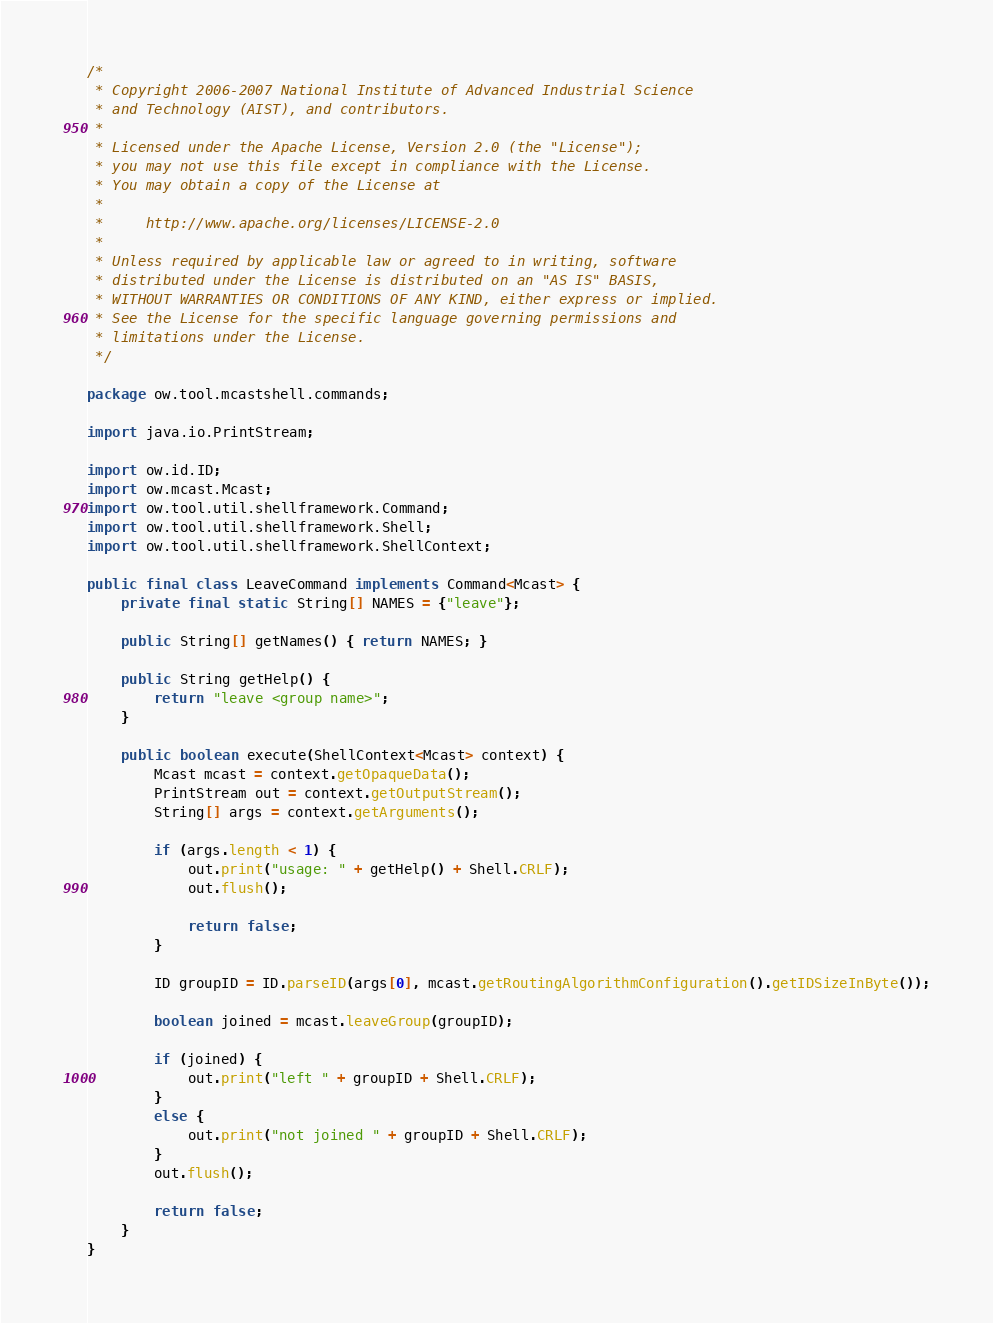<code> <loc_0><loc_0><loc_500><loc_500><_Java_>/*
 * Copyright 2006-2007 National Institute of Advanced Industrial Science
 * and Technology (AIST), and contributors.
 *
 * Licensed under the Apache License, Version 2.0 (the "License");
 * you may not use this file except in compliance with the License.
 * You may obtain a copy of the License at
 *
 *     http://www.apache.org/licenses/LICENSE-2.0
 *
 * Unless required by applicable law or agreed to in writing, software
 * distributed under the License is distributed on an "AS IS" BASIS,
 * WITHOUT WARRANTIES OR CONDITIONS OF ANY KIND, either express or implied.
 * See the License for the specific language governing permissions and
 * limitations under the License.
 */

package ow.tool.mcastshell.commands;

import java.io.PrintStream;

import ow.id.ID;
import ow.mcast.Mcast;
import ow.tool.util.shellframework.Command;
import ow.tool.util.shellframework.Shell;
import ow.tool.util.shellframework.ShellContext;

public final class LeaveCommand implements Command<Mcast> {
	private final static String[] NAMES = {"leave"};

	public String[] getNames() { return NAMES; }

	public String getHelp() {
		return "leave <group name>";
	}

	public boolean execute(ShellContext<Mcast> context) {
		Mcast mcast = context.getOpaqueData();
		PrintStream out = context.getOutputStream();
		String[] args = context.getArguments();

		if (args.length < 1) {
			out.print("usage: " + getHelp() + Shell.CRLF);
			out.flush();

			return false;
		}

		ID groupID = ID.parseID(args[0], mcast.getRoutingAlgorithmConfiguration().getIDSizeInByte());

		boolean joined = mcast.leaveGroup(groupID);

		if (joined) {
			out.print("left " + groupID + Shell.CRLF);
		}
		else {
			out.print("not joined " + groupID + Shell.CRLF);
		}
		out.flush();

		return false;
	}
}
</code> 